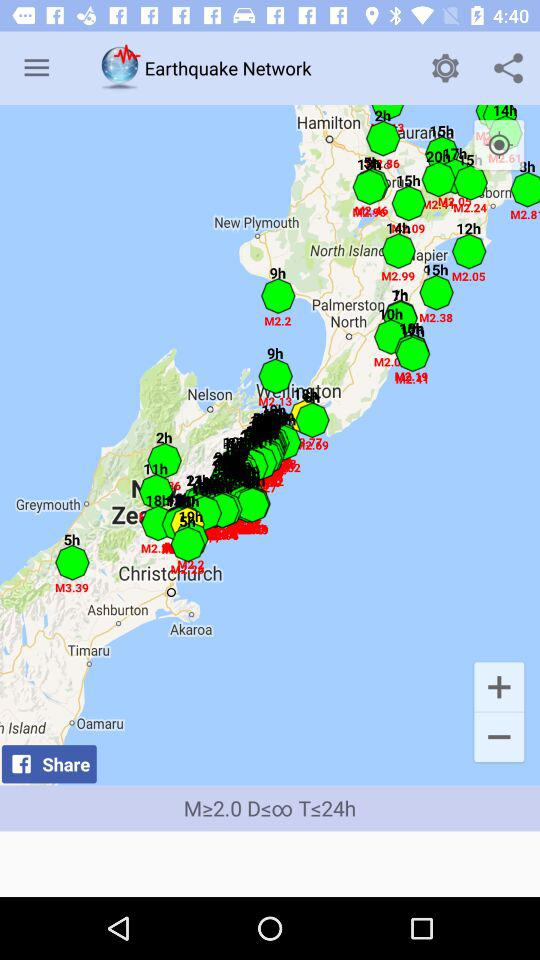Which location is selected?
When the provided information is insufficient, respond with <no answer>. <no answer> 